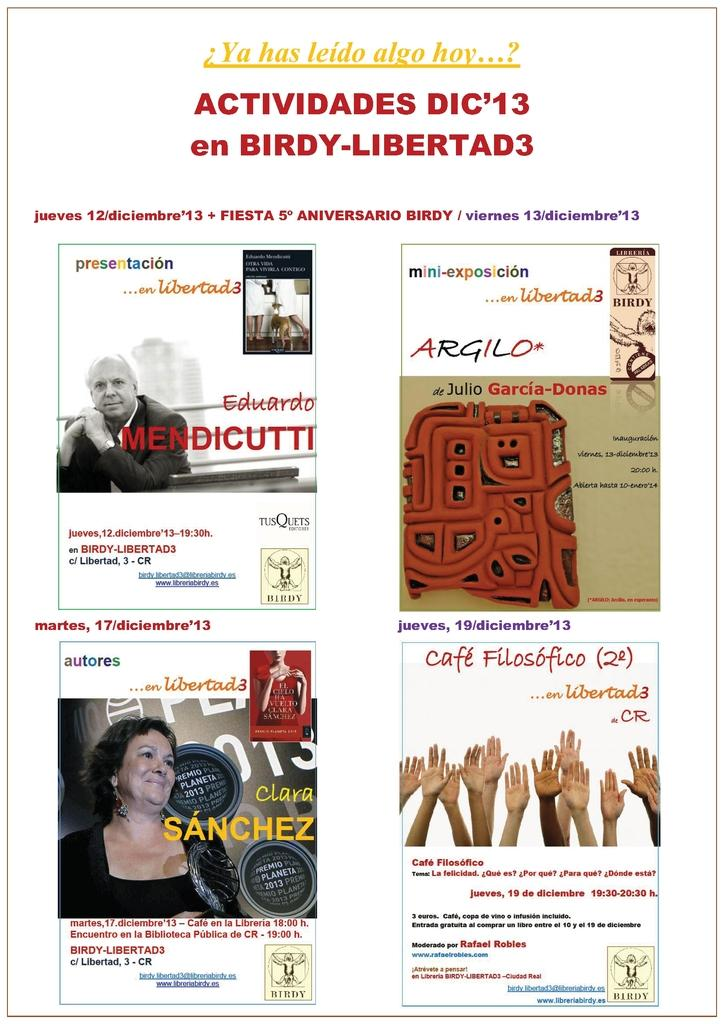What is present in the image that contains multiple images? There is a poster in the image that contains four images. What else can be found on the poster besides the images? There is text on the poster. What type of record can be seen spinning on the poster? There is no record present on the poster; it only contains images and text. 